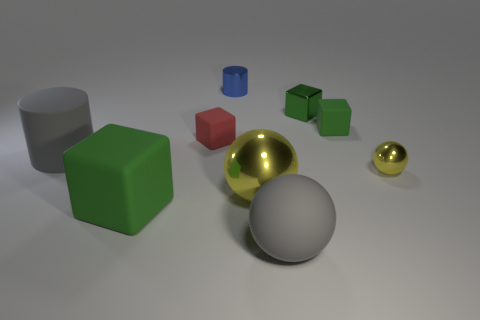What is the color of the small metallic thing in front of the tiny red rubber block?
Make the answer very short. Yellow. The big matte object that is the same shape as the small blue shiny thing is what color?
Offer a very short reply. Gray. There is a green block that is in front of the large ball that is behind the large rubber sphere; how many large yellow shiny things are to the right of it?
Keep it short and to the point. 1. Are there any other things that have the same material as the tiny cylinder?
Give a very brief answer. Yes. Are there fewer small green objects left of the large yellow metal sphere than tiny blue cylinders?
Provide a succinct answer. Yes. Is the color of the big shiny ball the same as the large cylinder?
Make the answer very short. No. The other yellow metallic thing that is the same shape as the tiny yellow shiny object is what size?
Offer a terse response. Large. What number of large gray spheres have the same material as the small red cube?
Offer a very short reply. 1. Is the material of the big gray thing that is on the right side of the tiny metallic cylinder the same as the big yellow object?
Offer a terse response. No. Are there the same number of small blue things that are right of the large cylinder and yellow shiny balls?
Offer a terse response. No. 